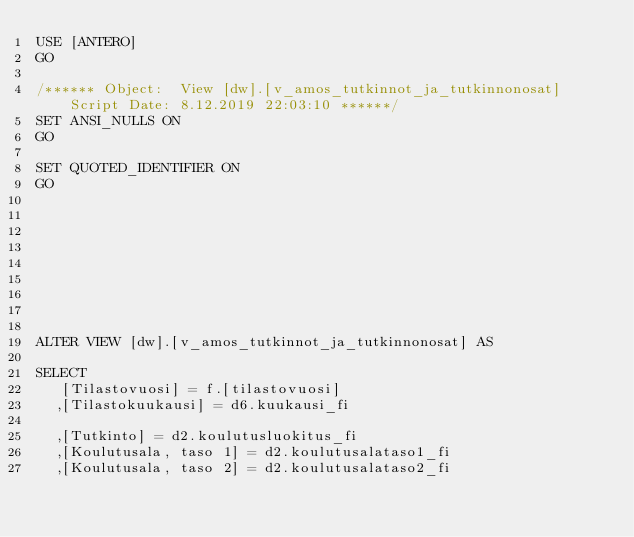Convert code to text. <code><loc_0><loc_0><loc_500><loc_500><_SQL_>USE [ANTERO]
GO

/****** Object:  View [dw].[v_amos_tutkinnot_ja_tutkinnonosat]    Script Date: 8.12.2019 22:03:10 ******/
SET ANSI_NULLS ON
GO

SET QUOTED_IDENTIFIER ON
GO









ALTER VIEW [dw].[v_amos_tutkinnot_ja_tutkinnonosat] AS

SELECT 
	 [Tilastovuosi] = f.[tilastovuosi]
	,[Tilastokuukausi] = d6.kuukausi_fi

	,[Tutkinto] = d2.koulutusluokitus_fi
	,[Koulutusala, taso 1] = d2.koulutusalataso1_fi
	,[Koulutusala, taso 2] = d2.koulutusalataso2_fi</code> 